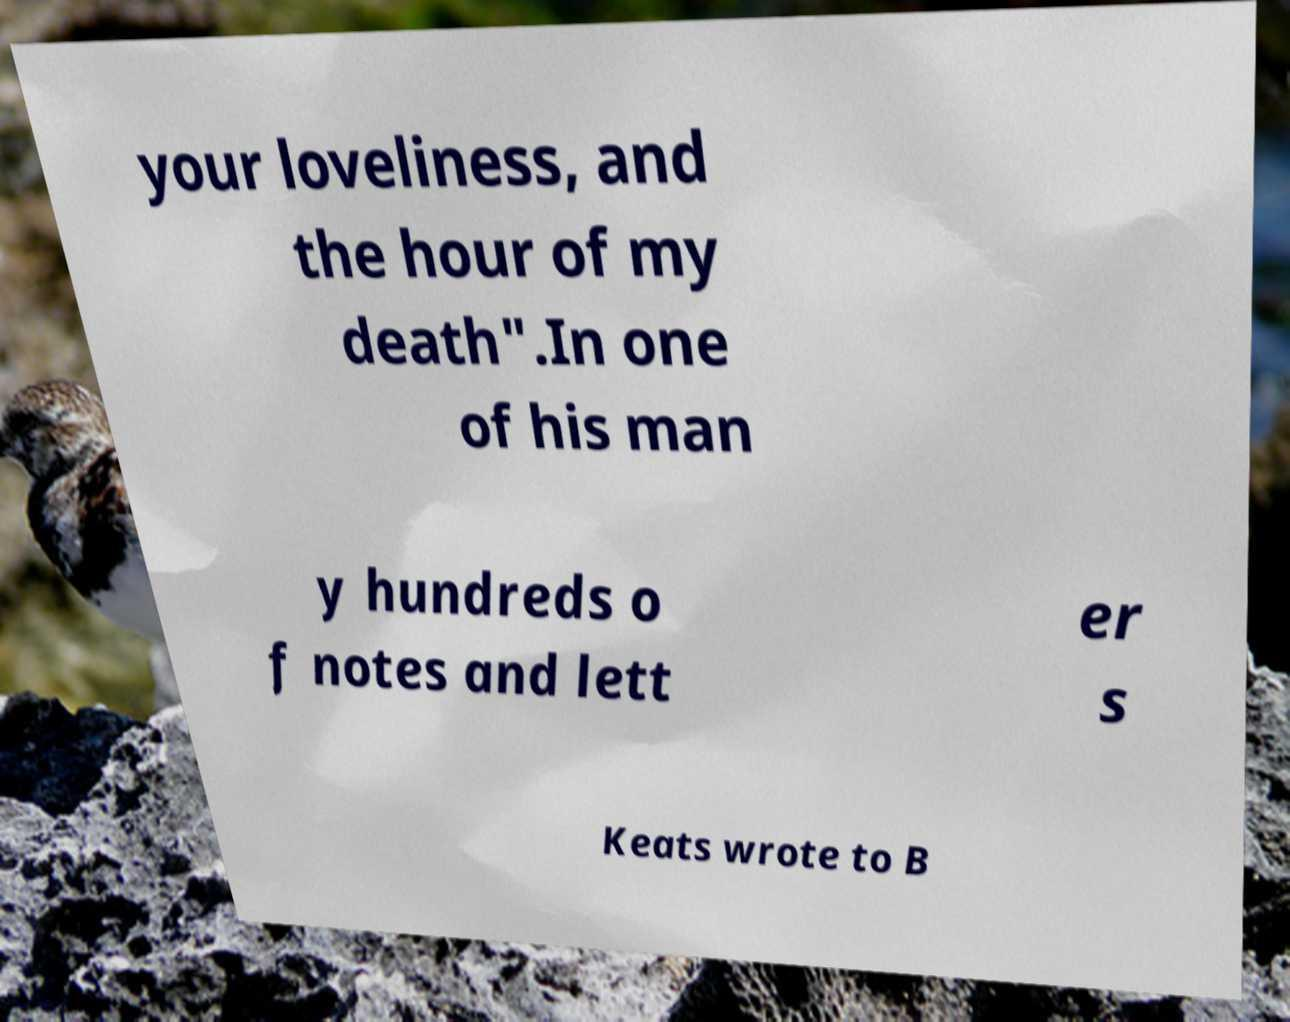Could you extract and type out the text from this image? your loveliness, and the hour of my death".In one of his man y hundreds o f notes and lett er s Keats wrote to B 